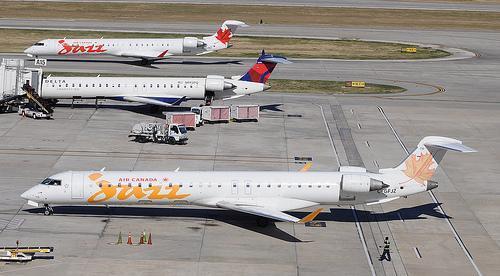How many planes are there?
Give a very brief answer. 3. 